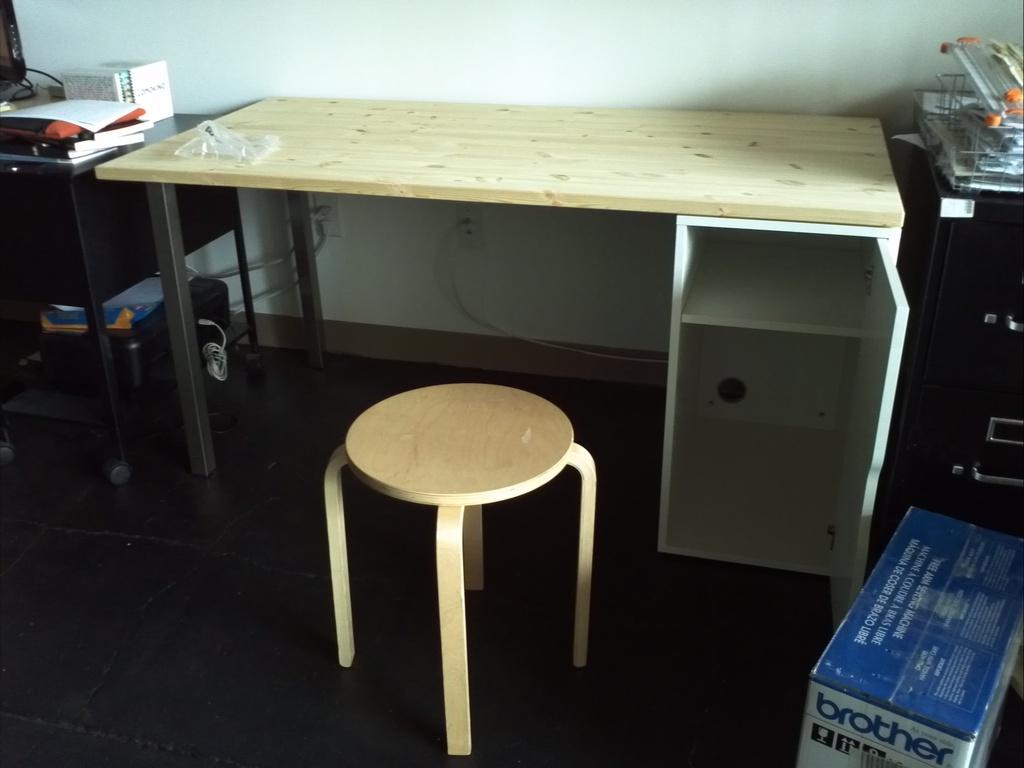What family title is mentioned on the box below?
Make the answer very short. Brother. What brand printer is in the box on the floor?
Your answer should be very brief. Brother. 